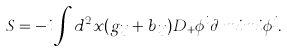<formula> <loc_0><loc_0><loc_500><loc_500>S & = - i \int d { ^ { 2 } x } ( g _ { i j } + b _ { i j } ) D _ { + } \phi ^ { i } \partial _ { \ } m i m i \phi ^ { j } .</formula> 